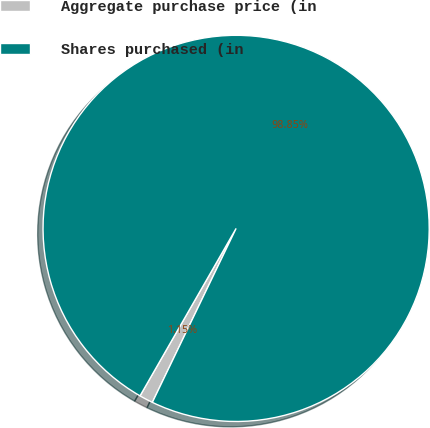<chart> <loc_0><loc_0><loc_500><loc_500><pie_chart><fcel>Aggregate purchase price (in<fcel>Shares purchased (in<nl><fcel>1.15%<fcel>98.85%<nl></chart> 